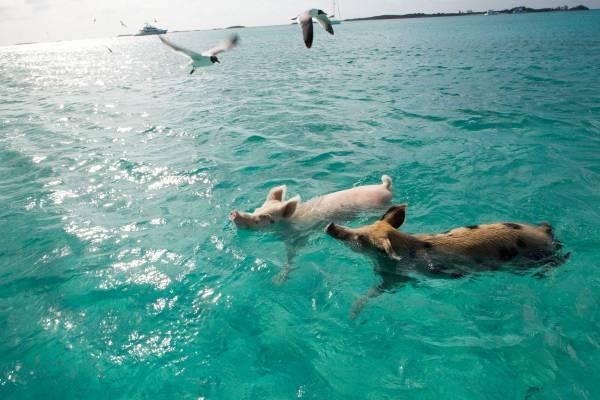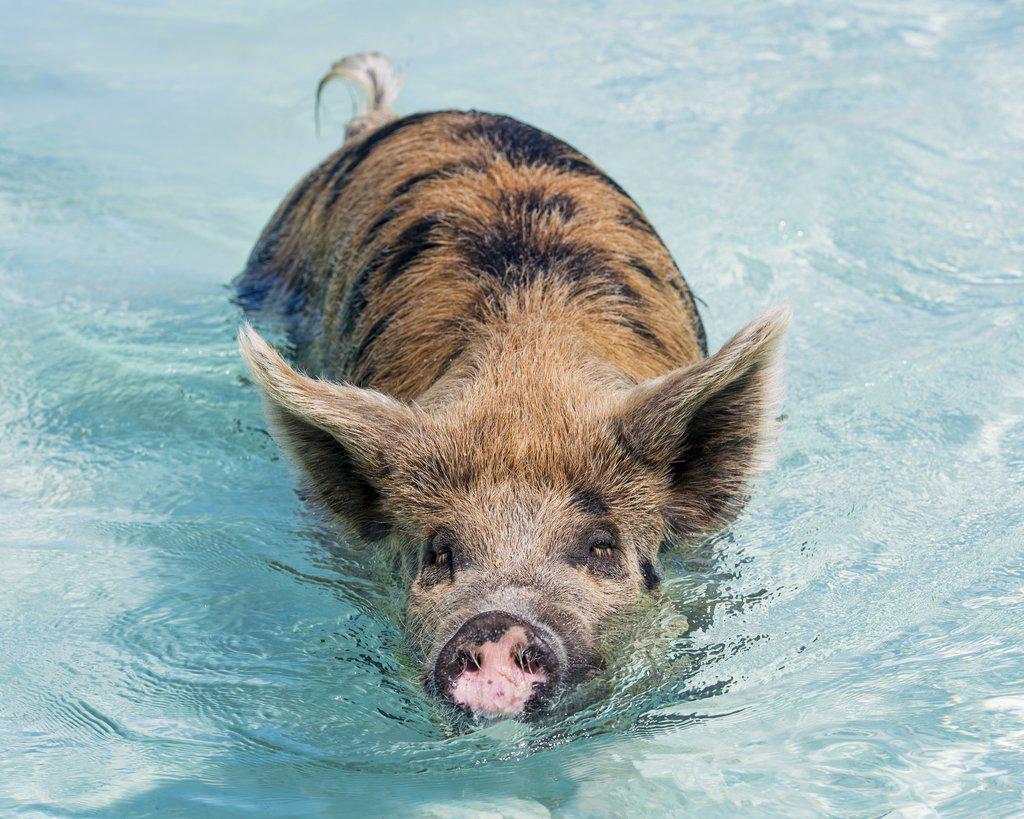The first image is the image on the left, the second image is the image on the right. Given the left and right images, does the statement "There is one pig in the right image." hold true? Answer yes or no. Yes. The first image is the image on the left, the second image is the image on the right. Given the left and right images, does the statement "The right image contains exactly one spotted pig, which is viewed from above and swimming toward the camera." hold true? Answer yes or no. Yes. 